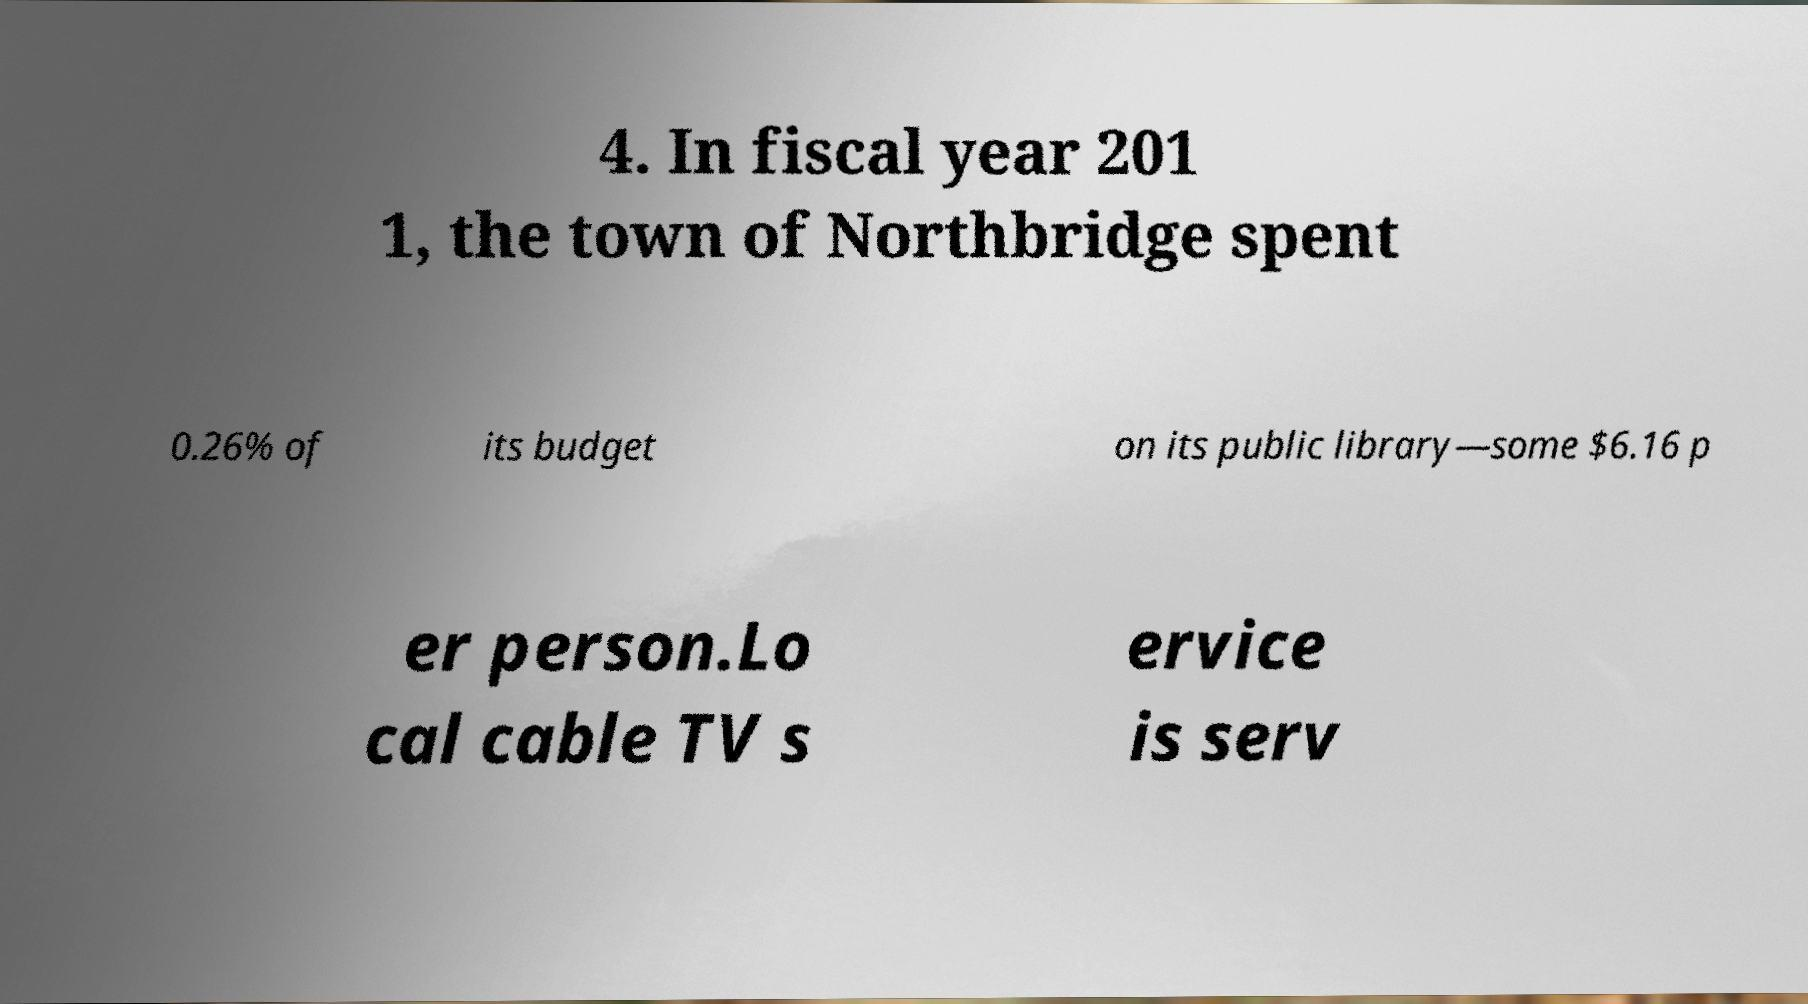Please read and relay the text visible in this image. What does it say? 4. In fiscal year 201 1, the town of Northbridge spent 0.26% of its budget on its public library—some $6.16 p er person.Lo cal cable TV s ervice is serv 